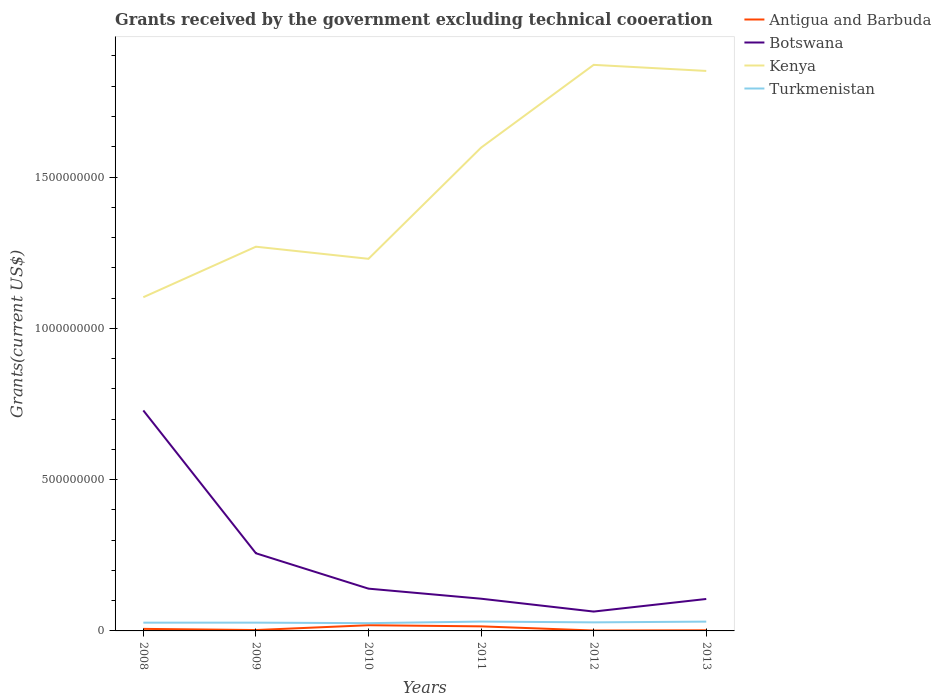Across all years, what is the maximum total grants received by the government in Turkmenistan?
Provide a short and direct response. 2.57e+07. In which year was the total grants received by the government in Turkmenistan maximum?
Your response must be concise. 2010. What is the total total grants received by the government in Turkmenistan in the graph?
Your response must be concise. -3.51e+06. What is the difference between the highest and the second highest total grants received by the government in Botswana?
Provide a succinct answer. 6.65e+08. What is the difference between the highest and the lowest total grants received by the government in Turkmenistan?
Provide a short and direct response. 2. Is the total grants received by the government in Botswana strictly greater than the total grants received by the government in Antigua and Barbuda over the years?
Give a very brief answer. No. How many lines are there?
Provide a succinct answer. 4. How many years are there in the graph?
Provide a short and direct response. 6. What is the difference between two consecutive major ticks on the Y-axis?
Make the answer very short. 5.00e+08. Are the values on the major ticks of Y-axis written in scientific E-notation?
Make the answer very short. No. Where does the legend appear in the graph?
Provide a short and direct response. Top right. How many legend labels are there?
Ensure brevity in your answer.  4. How are the legend labels stacked?
Provide a succinct answer. Vertical. What is the title of the graph?
Ensure brevity in your answer.  Grants received by the government excluding technical cooeration. What is the label or title of the Y-axis?
Offer a terse response. Grants(current US$). What is the Grants(current US$) in Antigua and Barbuda in 2008?
Your response must be concise. 6.78e+06. What is the Grants(current US$) in Botswana in 2008?
Ensure brevity in your answer.  7.29e+08. What is the Grants(current US$) in Kenya in 2008?
Keep it short and to the point. 1.10e+09. What is the Grants(current US$) in Turkmenistan in 2008?
Your answer should be compact. 2.73e+07. What is the Grants(current US$) of Antigua and Barbuda in 2009?
Provide a short and direct response. 2.92e+06. What is the Grants(current US$) of Botswana in 2009?
Your answer should be very brief. 2.57e+08. What is the Grants(current US$) in Kenya in 2009?
Ensure brevity in your answer.  1.27e+09. What is the Grants(current US$) of Turkmenistan in 2009?
Keep it short and to the point. 2.74e+07. What is the Grants(current US$) in Antigua and Barbuda in 2010?
Ensure brevity in your answer.  1.88e+07. What is the Grants(current US$) of Botswana in 2010?
Give a very brief answer. 1.40e+08. What is the Grants(current US$) in Kenya in 2010?
Keep it short and to the point. 1.23e+09. What is the Grants(current US$) of Turkmenistan in 2010?
Offer a terse response. 2.57e+07. What is the Grants(current US$) in Antigua and Barbuda in 2011?
Provide a succinct answer. 1.51e+07. What is the Grants(current US$) of Botswana in 2011?
Provide a short and direct response. 1.06e+08. What is the Grants(current US$) in Kenya in 2011?
Your response must be concise. 1.60e+09. What is the Grants(current US$) in Turkmenistan in 2011?
Provide a succinct answer. 3.09e+07. What is the Grants(current US$) in Antigua and Barbuda in 2012?
Provide a short and direct response. 1.38e+06. What is the Grants(current US$) in Botswana in 2012?
Provide a succinct answer. 6.40e+07. What is the Grants(current US$) of Kenya in 2012?
Ensure brevity in your answer.  1.87e+09. What is the Grants(current US$) in Turkmenistan in 2012?
Keep it short and to the point. 2.83e+07. What is the Grants(current US$) in Antigua and Barbuda in 2013?
Keep it short and to the point. 2.06e+06. What is the Grants(current US$) in Botswana in 2013?
Your answer should be compact. 1.06e+08. What is the Grants(current US$) of Kenya in 2013?
Provide a succinct answer. 1.85e+09. What is the Grants(current US$) of Turkmenistan in 2013?
Your response must be concise. 3.07e+07. Across all years, what is the maximum Grants(current US$) of Antigua and Barbuda?
Provide a succinct answer. 1.88e+07. Across all years, what is the maximum Grants(current US$) in Botswana?
Keep it short and to the point. 7.29e+08. Across all years, what is the maximum Grants(current US$) in Kenya?
Your response must be concise. 1.87e+09. Across all years, what is the maximum Grants(current US$) in Turkmenistan?
Give a very brief answer. 3.09e+07. Across all years, what is the minimum Grants(current US$) in Antigua and Barbuda?
Give a very brief answer. 1.38e+06. Across all years, what is the minimum Grants(current US$) of Botswana?
Make the answer very short. 6.40e+07. Across all years, what is the minimum Grants(current US$) in Kenya?
Provide a short and direct response. 1.10e+09. Across all years, what is the minimum Grants(current US$) in Turkmenistan?
Ensure brevity in your answer.  2.57e+07. What is the total Grants(current US$) in Antigua and Barbuda in the graph?
Offer a terse response. 4.70e+07. What is the total Grants(current US$) in Botswana in the graph?
Offer a terse response. 1.40e+09. What is the total Grants(current US$) of Kenya in the graph?
Provide a succinct answer. 8.92e+09. What is the total Grants(current US$) in Turkmenistan in the graph?
Your answer should be very brief. 1.70e+08. What is the difference between the Grants(current US$) in Antigua and Barbuda in 2008 and that in 2009?
Provide a succinct answer. 3.86e+06. What is the difference between the Grants(current US$) of Botswana in 2008 and that in 2009?
Keep it short and to the point. 4.72e+08. What is the difference between the Grants(current US$) in Kenya in 2008 and that in 2009?
Your response must be concise. -1.67e+08. What is the difference between the Grants(current US$) in Turkmenistan in 2008 and that in 2009?
Your answer should be compact. -6.00e+04. What is the difference between the Grants(current US$) in Antigua and Barbuda in 2008 and that in 2010?
Make the answer very short. -1.20e+07. What is the difference between the Grants(current US$) in Botswana in 2008 and that in 2010?
Offer a terse response. 5.89e+08. What is the difference between the Grants(current US$) in Kenya in 2008 and that in 2010?
Keep it short and to the point. -1.27e+08. What is the difference between the Grants(current US$) of Turkmenistan in 2008 and that in 2010?
Provide a short and direct response. 1.63e+06. What is the difference between the Grants(current US$) of Antigua and Barbuda in 2008 and that in 2011?
Offer a very short reply. -8.28e+06. What is the difference between the Grants(current US$) in Botswana in 2008 and that in 2011?
Your response must be concise. 6.22e+08. What is the difference between the Grants(current US$) of Kenya in 2008 and that in 2011?
Your response must be concise. -4.94e+08. What is the difference between the Grants(current US$) of Turkmenistan in 2008 and that in 2011?
Your answer should be very brief. -3.57e+06. What is the difference between the Grants(current US$) of Antigua and Barbuda in 2008 and that in 2012?
Your answer should be compact. 5.40e+06. What is the difference between the Grants(current US$) of Botswana in 2008 and that in 2012?
Your answer should be compact. 6.65e+08. What is the difference between the Grants(current US$) of Kenya in 2008 and that in 2012?
Provide a succinct answer. -7.68e+08. What is the difference between the Grants(current US$) of Turkmenistan in 2008 and that in 2012?
Give a very brief answer. -9.90e+05. What is the difference between the Grants(current US$) in Antigua and Barbuda in 2008 and that in 2013?
Provide a succinct answer. 4.72e+06. What is the difference between the Grants(current US$) of Botswana in 2008 and that in 2013?
Provide a short and direct response. 6.23e+08. What is the difference between the Grants(current US$) in Kenya in 2008 and that in 2013?
Your answer should be very brief. -7.48e+08. What is the difference between the Grants(current US$) of Turkmenistan in 2008 and that in 2013?
Your response must be concise. -3.41e+06. What is the difference between the Grants(current US$) of Antigua and Barbuda in 2009 and that in 2010?
Provide a succinct answer. -1.59e+07. What is the difference between the Grants(current US$) in Botswana in 2009 and that in 2010?
Give a very brief answer. 1.17e+08. What is the difference between the Grants(current US$) of Kenya in 2009 and that in 2010?
Provide a succinct answer. 4.00e+07. What is the difference between the Grants(current US$) of Turkmenistan in 2009 and that in 2010?
Keep it short and to the point. 1.69e+06. What is the difference between the Grants(current US$) in Antigua and Barbuda in 2009 and that in 2011?
Offer a terse response. -1.21e+07. What is the difference between the Grants(current US$) of Botswana in 2009 and that in 2011?
Provide a short and direct response. 1.50e+08. What is the difference between the Grants(current US$) of Kenya in 2009 and that in 2011?
Your answer should be very brief. -3.27e+08. What is the difference between the Grants(current US$) of Turkmenistan in 2009 and that in 2011?
Make the answer very short. -3.51e+06. What is the difference between the Grants(current US$) of Antigua and Barbuda in 2009 and that in 2012?
Give a very brief answer. 1.54e+06. What is the difference between the Grants(current US$) of Botswana in 2009 and that in 2012?
Keep it short and to the point. 1.93e+08. What is the difference between the Grants(current US$) in Kenya in 2009 and that in 2012?
Give a very brief answer. -6.01e+08. What is the difference between the Grants(current US$) in Turkmenistan in 2009 and that in 2012?
Offer a terse response. -9.30e+05. What is the difference between the Grants(current US$) of Antigua and Barbuda in 2009 and that in 2013?
Give a very brief answer. 8.60e+05. What is the difference between the Grants(current US$) in Botswana in 2009 and that in 2013?
Your answer should be compact. 1.51e+08. What is the difference between the Grants(current US$) of Kenya in 2009 and that in 2013?
Your answer should be very brief. -5.81e+08. What is the difference between the Grants(current US$) in Turkmenistan in 2009 and that in 2013?
Ensure brevity in your answer.  -3.35e+06. What is the difference between the Grants(current US$) of Antigua and Barbuda in 2010 and that in 2011?
Provide a short and direct response. 3.77e+06. What is the difference between the Grants(current US$) in Botswana in 2010 and that in 2011?
Provide a short and direct response. 3.32e+07. What is the difference between the Grants(current US$) in Kenya in 2010 and that in 2011?
Your answer should be compact. -3.67e+08. What is the difference between the Grants(current US$) of Turkmenistan in 2010 and that in 2011?
Give a very brief answer. -5.20e+06. What is the difference between the Grants(current US$) in Antigua and Barbuda in 2010 and that in 2012?
Make the answer very short. 1.74e+07. What is the difference between the Grants(current US$) in Botswana in 2010 and that in 2012?
Provide a succinct answer. 7.57e+07. What is the difference between the Grants(current US$) in Kenya in 2010 and that in 2012?
Keep it short and to the point. -6.41e+08. What is the difference between the Grants(current US$) of Turkmenistan in 2010 and that in 2012?
Give a very brief answer. -2.62e+06. What is the difference between the Grants(current US$) of Antigua and Barbuda in 2010 and that in 2013?
Your answer should be compact. 1.68e+07. What is the difference between the Grants(current US$) in Botswana in 2010 and that in 2013?
Offer a very short reply. 3.41e+07. What is the difference between the Grants(current US$) in Kenya in 2010 and that in 2013?
Keep it short and to the point. -6.21e+08. What is the difference between the Grants(current US$) of Turkmenistan in 2010 and that in 2013?
Your answer should be compact. -5.04e+06. What is the difference between the Grants(current US$) of Antigua and Barbuda in 2011 and that in 2012?
Your answer should be compact. 1.37e+07. What is the difference between the Grants(current US$) of Botswana in 2011 and that in 2012?
Your answer should be compact. 4.25e+07. What is the difference between the Grants(current US$) of Kenya in 2011 and that in 2012?
Your answer should be very brief. -2.74e+08. What is the difference between the Grants(current US$) of Turkmenistan in 2011 and that in 2012?
Your answer should be compact. 2.58e+06. What is the difference between the Grants(current US$) of Antigua and Barbuda in 2011 and that in 2013?
Your answer should be very brief. 1.30e+07. What is the difference between the Grants(current US$) in Botswana in 2011 and that in 2013?
Keep it short and to the point. 8.70e+05. What is the difference between the Grants(current US$) of Kenya in 2011 and that in 2013?
Provide a succinct answer. -2.53e+08. What is the difference between the Grants(current US$) of Turkmenistan in 2011 and that in 2013?
Give a very brief answer. 1.60e+05. What is the difference between the Grants(current US$) of Antigua and Barbuda in 2012 and that in 2013?
Your answer should be very brief. -6.80e+05. What is the difference between the Grants(current US$) of Botswana in 2012 and that in 2013?
Provide a succinct answer. -4.16e+07. What is the difference between the Grants(current US$) of Kenya in 2012 and that in 2013?
Offer a very short reply. 2.01e+07. What is the difference between the Grants(current US$) of Turkmenistan in 2012 and that in 2013?
Your answer should be compact. -2.42e+06. What is the difference between the Grants(current US$) of Antigua and Barbuda in 2008 and the Grants(current US$) of Botswana in 2009?
Offer a very short reply. -2.50e+08. What is the difference between the Grants(current US$) in Antigua and Barbuda in 2008 and the Grants(current US$) in Kenya in 2009?
Give a very brief answer. -1.26e+09. What is the difference between the Grants(current US$) in Antigua and Barbuda in 2008 and the Grants(current US$) in Turkmenistan in 2009?
Your response must be concise. -2.06e+07. What is the difference between the Grants(current US$) in Botswana in 2008 and the Grants(current US$) in Kenya in 2009?
Give a very brief answer. -5.41e+08. What is the difference between the Grants(current US$) of Botswana in 2008 and the Grants(current US$) of Turkmenistan in 2009?
Provide a succinct answer. 7.01e+08. What is the difference between the Grants(current US$) of Kenya in 2008 and the Grants(current US$) of Turkmenistan in 2009?
Provide a succinct answer. 1.08e+09. What is the difference between the Grants(current US$) in Antigua and Barbuda in 2008 and the Grants(current US$) in Botswana in 2010?
Your answer should be compact. -1.33e+08. What is the difference between the Grants(current US$) of Antigua and Barbuda in 2008 and the Grants(current US$) of Kenya in 2010?
Provide a succinct answer. -1.22e+09. What is the difference between the Grants(current US$) of Antigua and Barbuda in 2008 and the Grants(current US$) of Turkmenistan in 2010?
Your response must be concise. -1.89e+07. What is the difference between the Grants(current US$) of Botswana in 2008 and the Grants(current US$) of Kenya in 2010?
Your answer should be very brief. -5.01e+08. What is the difference between the Grants(current US$) in Botswana in 2008 and the Grants(current US$) in Turkmenistan in 2010?
Your response must be concise. 7.03e+08. What is the difference between the Grants(current US$) in Kenya in 2008 and the Grants(current US$) in Turkmenistan in 2010?
Your response must be concise. 1.08e+09. What is the difference between the Grants(current US$) of Antigua and Barbuda in 2008 and the Grants(current US$) of Botswana in 2011?
Give a very brief answer. -9.97e+07. What is the difference between the Grants(current US$) in Antigua and Barbuda in 2008 and the Grants(current US$) in Kenya in 2011?
Your answer should be compact. -1.59e+09. What is the difference between the Grants(current US$) of Antigua and Barbuda in 2008 and the Grants(current US$) of Turkmenistan in 2011?
Provide a succinct answer. -2.41e+07. What is the difference between the Grants(current US$) in Botswana in 2008 and the Grants(current US$) in Kenya in 2011?
Offer a terse response. -8.69e+08. What is the difference between the Grants(current US$) in Botswana in 2008 and the Grants(current US$) in Turkmenistan in 2011?
Offer a very short reply. 6.98e+08. What is the difference between the Grants(current US$) of Kenya in 2008 and the Grants(current US$) of Turkmenistan in 2011?
Ensure brevity in your answer.  1.07e+09. What is the difference between the Grants(current US$) of Antigua and Barbuda in 2008 and the Grants(current US$) of Botswana in 2012?
Offer a very short reply. -5.72e+07. What is the difference between the Grants(current US$) in Antigua and Barbuda in 2008 and the Grants(current US$) in Kenya in 2012?
Make the answer very short. -1.86e+09. What is the difference between the Grants(current US$) of Antigua and Barbuda in 2008 and the Grants(current US$) of Turkmenistan in 2012?
Provide a succinct answer. -2.15e+07. What is the difference between the Grants(current US$) in Botswana in 2008 and the Grants(current US$) in Kenya in 2012?
Ensure brevity in your answer.  -1.14e+09. What is the difference between the Grants(current US$) of Botswana in 2008 and the Grants(current US$) of Turkmenistan in 2012?
Keep it short and to the point. 7.00e+08. What is the difference between the Grants(current US$) of Kenya in 2008 and the Grants(current US$) of Turkmenistan in 2012?
Make the answer very short. 1.07e+09. What is the difference between the Grants(current US$) of Antigua and Barbuda in 2008 and the Grants(current US$) of Botswana in 2013?
Your answer should be very brief. -9.88e+07. What is the difference between the Grants(current US$) in Antigua and Barbuda in 2008 and the Grants(current US$) in Kenya in 2013?
Your answer should be compact. -1.84e+09. What is the difference between the Grants(current US$) of Antigua and Barbuda in 2008 and the Grants(current US$) of Turkmenistan in 2013?
Provide a succinct answer. -2.39e+07. What is the difference between the Grants(current US$) in Botswana in 2008 and the Grants(current US$) in Kenya in 2013?
Keep it short and to the point. -1.12e+09. What is the difference between the Grants(current US$) in Botswana in 2008 and the Grants(current US$) in Turkmenistan in 2013?
Keep it short and to the point. 6.98e+08. What is the difference between the Grants(current US$) in Kenya in 2008 and the Grants(current US$) in Turkmenistan in 2013?
Offer a very short reply. 1.07e+09. What is the difference between the Grants(current US$) of Antigua and Barbuda in 2009 and the Grants(current US$) of Botswana in 2010?
Provide a succinct answer. -1.37e+08. What is the difference between the Grants(current US$) in Antigua and Barbuda in 2009 and the Grants(current US$) in Kenya in 2010?
Provide a short and direct response. -1.23e+09. What is the difference between the Grants(current US$) in Antigua and Barbuda in 2009 and the Grants(current US$) in Turkmenistan in 2010?
Ensure brevity in your answer.  -2.28e+07. What is the difference between the Grants(current US$) of Botswana in 2009 and the Grants(current US$) of Kenya in 2010?
Your answer should be very brief. -9.73e+08. What is the difference between the Grants(current US$) in Botswana in 2009 and the Grants(current US$) in Turkmenistan in 2010?
Your response must be concise. 2.31e+08. What is the difference between the Grants(current US$) of Kenya in 2009 and the Grants(current US$) of Turkmenistan in 2010?
Provide a short and direct response. 1.24e+09. What is the difference between the Grants(current US$) in Antigua and Barbuda in 2009 and the Grants(current US$) in Botswana in 2011?
Provide a succinct answer. -1.04e+08. What is the difference between the Grants(current US$) of Antigua and Barbuda in 2009 and the Grants(current US$) of Kenya in 2011?
Ensure brevity in your answer.  -1.59e+09. What is the difference between the Grants(current US$) in Antigua and Barbuda in 2009 and the Grants(current US$) in Turkmenistan in 2011?
Your answer should be very brief. -2.80e+07. What is the difference between the Grants(current US$) in Botswana in 2009 and the Grants(current US$) in Kenya in 2011?
Provide a short and direct response. -1.34e+09. What is the difference between the Grants(current US$) of Botswana in 2009 and the Grants(current US$) of Turkmenistan in 2011?
Ensure brevity in your answer.  2.26e+08. What is the difference between the Grants(current US$) in Kenya in 2009 and the Grants(current US$) in Turkmenistan in 2011?
Your answer should be compact. 1.24e+09. What is the difference between the Grants(current US$) of Antigua and Barbuda in 2009 and the Grants(current US$) of Botswana in 2012?
Keep it short and to the point. -6.10e+07. What is the difference between the Grants(current US$) in Antigua and Barbuda in 2009 and the Grants(current US$) in Kenya in 2012?
Provide a succinct answer. -1.87e+09. What is the difference between the Grants(current US$) in Antigua and Barbuda in 2009 and the Grants(current US$) in Turkmenistan in 2012?
Provide a short and direct response. -2.54e+07. What is the difference between the Grants(current US$) of Botswana in 2009 and the Grants(current US$) of Kenya in 2012?
Offer a terse response. -1.61e+09. What is the difference between the Grants(current US$) in Botswana in 2009 and the Grants(current US$) in Turkmenistan in 2012?
Ensure brevity in your answer.  2.28e+08. What is the difference between the Grants(current US$) in Kenya in 2009 and the Grants(current US$) in Turkmenistan in 2012?
Your answer should be compact. 1.24e+09. What is the difference between the Grants(current US$) of Antigua and Barbuda in 2009 and the Grants(current US$) of Botswana in 2013?
Make the answer very short. -1.03e+08. What is the difference between the Grants(current US$) in Antigua and Barbuda in 2009 and the Grants(current US$) in Kenya in 2013?
Your answer should be compact. -1.85e+09. What is the difference between the Grants(current US$) of Antigua and Barbuda in 2009 and the Grants(current US$) of Turkmenistan in 2013?
Make the answer very short. -2.78e+07. What is the difference between the Grants(current US$) of Botswana in 2009 and the Grants(current US$) of Kenya in 2013?
Your response must be concise. -1.59e+09. What is the difference between the Grants(current US$) of Botswana in 2009 and the Grants(current US$) of Turkmenistan in 2013?
Ensure brevity in your answer.  2.26e+08. What is the difference between the Grants(current US$) in Kenya in 2009 and the Grants(current US$) in Turkmenistan in 2013?
Keep it short and to the point. 1.24e+09. What is the difference between the Grants(current US$) in Antigua and Barbuda in 2010 and the Grants(current US$) in Botswana in 2011?
Provide a succinct answer. -8.76e+07. What is the difference between the Grants(current US$) in Antigua and Barbuda in 2010 and the Grants(current US$) in Kenya in 2011?
Your answer should be very brief. -1.58e+09. What is the difference between the Grants(current US$) of Antigua and Barbuda in 2010 and the Grants(current US$) of Turkmenistan in 2011?
Your answer should be compact. -1.20e+07. What is the difference between the Grants(current US$) in Botswana in 2010 and the Grants(current US$) in Kenya in 2011?
Offer a terse response. -1.46e+09. What is the difference between the Grants(current US$) in Botswana in 2010 and the Grants(current US$) in Turkmenistan in 2011?
Offer a terse response. 1.09e+08. What is the difference between the Grants(current US$) of Kenya in 2010 and the Grants(current US$) of Turkmenistan in 2011?
Your answer should be compact. 1.20e+09. What is the difference between the Grants(current US$) of Antigua and Barbuda in 2010 and the Grants(current US$) of Botswana in 2012?
Your response must be concise. -4.51e+07. What is the difference between the Grants(current US$) in Antigua and Barbuda in 2010 and the Grants(current US$) in Kenya in 2012?
Keep it short and to the point. -1.85e+09. What is the difference between the Grants(current US$) of Antigua and Barbuda in 2010 and the Grants(current US$) of Turkmenistan in 2012?
Offer a very short reply. -9.46e+06. What is the difference between the Grants(current US$) in Botswana in 2010 and the Grants(current US$) in Kenya in 2012?
Give a very brief answer. -1.73e+09. What is the difference between the Grants(current US$) of Botswana in 2010 and the Grants(current US$) of Turkmenistan in 2012?
Your answer should be very brief. 1.11e+08. What is the difference between the Grants(current US$) in Kenya in 2010 and the Grants(current US$) in Turkmenistan in 2012?
Make the answer very short. 1.20e+09. What is the difference between the Grants(current US$) of Antigua and Barbuda in 2010 and the Grants(current US$) of Botswana in 2013?
Keep it short and to the point. -8.68e+07. What is the difference between the Grants(current US$) in Antigua and Barbuda in 2010 and the Grants(current US$) in Kenya in 2013?
Your response must be concise. -1.83e+09. What is the difference between the Grants(current US$) in Antigua and Barbuda in 2010 and the Grants(current US$) in Turkmenistan in 2013?
Your answer should be compact. -1.19e+07. What is the difference between the Grants(current US$) of Botswana in 2010 and the Grants(current US$) of Kenya in 2013?
Offer a very short reply. -1.71e+09. What is the difference between the Grants(current US$) of Botswana in 2010 and the Grants(current US$) of Turkmenistan in 2013?
Keep it short and to the point. 1.09e+08. What is the difference between the Grants(current US$) of Kenya in 2010 and the Grants(current US$) of Turkmenistan in 2013?
Provide a succinct answer. 1.20e+09. What is the difference between the Grants(current US$) in Antigua and Barbuda in 2011 and the Grants(current US$) in Botswana in 2012?
Your answer should be compact. -4.89e+07. What is the difference between the Grants(current US$) in Antigua and Barbuda in 2011 and the Grants(current US$) in Kenya in 2012?
Make the answer very short. -1.86e+09. What is the difference between the Grants(current US$) in Antigua and Barbuda in 2011 and the Grants(current US$) in Turkmenistan in 2012?
Your answer should be compact. -1.32e+07. What is the difference between the Grants(current US$) in Botswana in 2011 and the Grants(current US$) in Kenya in 2012?
Provide a succinct answer. -1.76e+09. What is the difference between the Grants(current US$) in Botswana in 2011 and the Grants(current US$) in Turkmenistan in 2012?
Offer a terse response. 7.82e+07. What is the difference between the Grants(current US$) in Kenya in 2011 and the Grants(current US$) in Turkmenistan in 2012?
Ensure brevity in your answer.  1.57e+09. What is the difference between the Grants(current US$) in Antigua and Barbuda in 2011 and the Grants(current US$) in Botswana in 2013?
Provide a short and direct response. -9.05e+07. What is the difference between the Grants(current US$) in Antigua and Barbuda in 2011 and the Grants(current US$) in Kenya in 2013?
Provide a short and direct response. -1.84e+09. What is the difference between the Grants(current US$) of Antigua and Barbuda in 2011 and the Grants(current US$) of Turkmenistan in 2013?
Make the answer very short. -1.56e+07. What is the difference between the Grants(current US$) in Botswana in 2011 and the Grants(current US$) in Kenya in 2013?
Offer a very short reply. -1.74e+09. What is the difference between the Grants(current US$) in Botswana in 2011 and the Grants(current US$) in Turkmenistan in 2013?
Provide a succinct answer. 7.57e+07. What is the difference between the Grants(current US$) of Kenya in 2011 and the Grants(current US$) of Turkmenistan in 2013?
Offer a very short reply. 1.57e+09. What is the difference between the Grants(current US$) of Antigua and Barbuda in 2012 and the Grants(current US$) of Botswana in 2013?
Keep it short and to the point. -1.04e+08. What is the difference between the Grants(current US$) of Antigua and Barbuda in 2012 and the Grants(current US$) of Kenya in 2013?
Give a very brief answer. -1.85e+09. What is the difference between the Grants(current US$) of Antigua and Barbuda in 2012 and the Grants(current US$) of Turkmenistan in 2013?
Keep it short and to the point. -2.93e+07. What is the difference between the Grants(current US$) of Botswana in 2012 and the Grants(current US$) of Kenya in 2013?
Ensure brevity in your answer.  -1.79e+09. What is the difference between the Grants(current US$) of Botswana in 2012 and the Grants(current US$) of Turkmenistan in 2013?
Your answer should be compact. 3.33e+07. What is the difference between the Grants(current US$) of Kenya in 2012 and the Grants(current US$) of Turkmenistan in 2013?
Your response must be concise. 1.84e+09. What is the average Grants(current US$) of Antigua and Barbuda per year?
Provide a short and direct response. 7.84e+06. What is the average Grants(current US$) of Botswana per year?
Provide a succinct answer. 2.33e+08. What is the average Grants(current US$) in Kenya per year?
Offer a very short reply. 1.49e+09. What is the average Grants(current US$) in Turkmenistan per year?
Your answer should be very brief. 2.84e+07. In the year 2008, what is the difference between the Grants(current US$) in Antigua and Barbuda and Grants(current US$) in Botswana?
Offer a very short reply. -7.22e+08. In the year 2008, what is the difference between the Grants(current US$) in Antigua and Barbuda and Grants(current US$) in Kenya?
Your response must be concise. -1.10e+09. In the year 2008, what is the difference between the Grants(current US$) of Antigua and Barbuda and Grants(current US$) of Turkmenistan?
Your answer should be compact. -2.05e+07. In the year 2008, what is the difference between the Grants(current US$) in Botswana and Grants(current US$) in Kenya?
Make the answer very short. -3.74e+08. In the year 2008, what is the difference between the Grants(current US$) of Botswana and Grants(current US$) of Turkmenistan?
Offer a terse response. 7.01e+08. In the year 2008, what is the difference between the Grants(current US$) of Kenya and Grants(current US$) of Turkmenistan?
Your answer should be compact. 1.08e+09. In the year 2009, what is the difference between the Grants(current US$) of Antigua and Barbuda and Grants(current US$) of Botswana?
Your answer should be very brief. -2.54e+08. In the year 2009, what is the difference between the Grants(current US$) of Antigua and Barbuda and Grants(current US$) of Kenya?
Make the answer very short. -1.27e+09. In the year 2009, what is the difference between the Grants(current US$) in Antigua and Barbuda and Grants(current US$) in Turkmenistan?
Your response must be concise. -2.44e+07. In the year 2009, what is the difference between the Grants(current US$) of Botswana and Grants(current US$) of Kenya?
Give a very brief answer. -1.01e+09. In the year 2009, what is the difference between the Grants(current US$) in Botswana and Grants(current US$) in Turkmenistan?
Your answer should be compact. 2.29e+08. In the year 2009, what is the difference between the Grants(current US$) in Kenya and Grants(current US$) in Turkmenistan?
Keep it short and to the point. 1.24e+09. In the year 2010, what is the difference between the Grants(current US$) of Antigua and Barbuda and Grants(current US$) of Botswana?
Offer a terse response. -1.21e+08. In the year 2010, what is the difference between the Grants(current US$) in Antigua and Barbuda and Grants(current US$) in Kenya?
Provide a succinct answer. -1.21e+09. In the year 2010, what is the difference between the Grants(current US$) in Antigua and Barbuda and Grants(current US$) in Turkmenistan?
Offer a very short reply. -6.84e+06. In the year 2010, what is the difference between the Grants(current US$) of Botswana and Grants(current US$) of Kenya?
Ensure brevity in your answer.  -1.09e+09. In the year 2010, what is the difference between the Grants(current US$) in Botswana and Grants(current US$) in Turkmenistan?
Provide a succinct answer. 1.14e+08. In the year 2010, what is the difference between the Grants(current US$) of Kenya and Grants(current US$) of Turkmenistan?
Keep it short and to the point. 1.20e+09. In the year 2011, what is the difference between the Grants(current US$) of Antigua and Barbuda and Grants(current US$) of Botswana?
Your answer should be compact. -9.14e+07. In the year 2011, what is the difference between the Grants(current US$) in Antigua and Barbuda and Grants(current US$) in Kenya?
Give a very brief answer. -1.58e+09. In the year 2011, what is the difference between the Grants(current US$) of Antigua and Barbuda and Grants(current US$) of Turkmenistan?
Offer a terse response. -1.58e+07. In the year 2011, what is the difference between the Grants(current US$) in Botswana and Grants(current US$) in Kenya?
Ensure brevity in your answer.  -1.49e+09. In the year 2011, what is the difference between the Grants(current US$) in Botswana and Grants(current US$) in Turkmenistan?
Offer a very short reply. 7.56e+07. In the year 2011, what is the difference between the Grants(current US$) in Kenya and Grants(current US$) in Turkmenistan?
Your answer should be very brief. 1.57e+09. In the year 2012, what is the difference between the Grants(current US$) in Antigua and Barbuda and Grants(current US$) in Botswana?
Give a very brief answer. -6.26e+07. In the year 2012, what is the difference between the Grants(current US$) of Antigua and Barbuda and Grants(current US$) of Kenya?
Offer a very short reply. -1.87e+09. In the year 2012, what is the difference between the Grants(current US$) in Antigua and Barbuda and Grants(current US$) in Turkmenistan?
Keep it short and to the point. -2.69e+07. In the year 2012, what is the difference between the Grants(current US$) in Botswana and Grants(current US$) in Kenya?
Your answer should be compact. -1.81e+09. In the year 2012, what is the difference between the Grants(current US$) of Botswana and Grants(current US$) of Turkmenistan?
Ensure brevity in your answer.  3.57e+07. In the year 2012, what is the difference between the Grants(current US$) in Kenya and Grants(current US$) in Turkmenistan?
Offer a terse response. 1.84e+09. In the year 2013, what is the difference between the Grants(current US$) in Antigua and Barbuda and Grants(current US$) in Botswana?
Give a very brief answer. -1.04e+08. In the year 2013, what is the difference between the Grants(current US$) in Antigua and Barbuda and Grants(current US$) in Kenya?
Your answer should be compact. -1.85e+09. In the year 2013, what is the difference between the Grants(current US$) of Antigua and Barbuda and Grants(current US$) of Turkmenistan?
Your answer should be compact. -2.86e+07. In the year 2013, what is the difference between the Grants(current US$) of Botswana and Grants(current US$) of Kenya?
Your answer should be very brief. -1.74e+09. In the year 2013, what is the difference between the Grants(current US$) of Botswana and Grants(current US$) of Turkmenistan?
Ensure brevity in your answer.  7.49e+07. In the year 2013, what is the difference between the Grants(current US$) of Kenya and Grants(current US$) of Turkmenistan?
Keep it short and to the point. 1.82e+09. What is the ratio of the Grants(current US$) of Antigua and Barbuda in 2008 to that in 2009?
Keep it short and to the point. 2.32. What is the ratio of the Grants(current US$) of Botswana in 2008 to that in 2009?
Your answer should be compact. 2.84. What is the ratio of the Grants(current US$) of Kenya in 2008 to that in 2009?
Offer a very short reply. 0.87. What is the ratio of the Grants(current US$) of Antigua and Barbuda in 2008 to that in 2010?
Your answer should be compact. 0.36. What is the ratio of the Grants(current US$) of Botswana in 2008 to that in 2010?
Ensure brevity in your answer.  5.22. What is the ratio of the Grants(current US$) of Kenya in 2008 to that in 2010?
Your response must be concise. 0.9. What is the ratio of the Grants(current US$) of Turkmenistan in 2008 to that in 2010?
Offer a very short reply. 1.06. What is the ratio of the Grants(current US$) in Antigua and Barbuda in 2008 to that in 2011?
Your answer should be very brief. 0.45. What is the ratio of the Grants(current US$) of Botswana in 2008 to that in 2011?
Your answer should be compact. 6.84. What is the ratio of the Grants(current US$) in Kenya in 2008 to that in 2011?
Give a very brief answer. 0.69. What is the ratio of the Grants(current US$) in Turkmenistan in 2008 to that in 2011?
Ensure brevity in your answer.  0.88. What is the ratio of the Grants(current US$) of Antigua and Barbuda in 2008 to that in 2012?
Keep it short and to the point. 4.91. What is the ratio of the Grants(current US$) of Botswana in 2008 to that in 2012?
Make the answer very short. 11.39. What is the ratio of the Grants(current US$) of Kenya in 2008 to that in 2012?
Provide a short and direct response. 0.59. What is the ratio of the Grants(current US$) of Turkmenistan in 2008 to that in 2012?
Provide a succinct answer. 0.96. What is the ratio of the Grants(current US$) of Antigua and Barbuda in 2008 to that in 2013?
Offer a terse response. 3.29. What is the ratio of the Grants(current US$) in Botswana in 2008 to that in 2013?
Provide a short and direct response. 6.9. What is the ratio of the Grants(current US$) in Kenya in 2008 to that in 2013?
Keep it short and to the point. 0.6. What is the ratio of the Grants(current US$) of Turkmenistan in 2008 to that in 2013?
Provide a short and direct response. 0.89. What is the ratio of the Grants(current US$) in Antigua and Barbuda in 2009 to that in 2010?
Offer a very short reply. 0.16. What is the ratio of the Grants(current US$) in Botswana in 2009 to that in 2010?
Provide a succinct answer. 1.84. What is the ratio of the Grants(current US$) of Kenya in 2009 to that in 2010?
Ensure brevity in your answer.  1.03. What is the ratio of the Grants(current US$) of Turkmenistan in 2009 to that in 2010?
Make the answer very short. 1.07. What is the ratio of the Grants(current US$) of Antigua and Barbuda in 2009 to that in 2011?
Give a very brief answer. 0.19. What is the ratio of the Grants(current US$) of Botswana in 2009 to that in 2011?
Your answer should be compact. 2.41. What is the ratio of the Grants(current US$) of Kenya in 2009 to that in 2011?
Provide a succinct answer. 0.8. What is the ratio of the Grants(current US$) of Turkmenistan in 2009 to that in 2011?
Your answer should be compact. 0.89. What is the ratio of the Grants(current US$) in Antigua and Barbuda in 2009 to that in 2012?
Offer a terse response. 2.12. What is the ratio of the Grants(current US$) in Botswana in 2009 to that in 2012?
Offer a very short reply. 4.01. What is the ratio of the Grants(current US$) in Kenya in 2009 to that in 2012?
Make the answer very short. 0.68. What is the ratio of the Grants(current US$) in Turkmenistan in 2009 to that in 2012?
Your answer should be very brief. 0.97. What is the ratio of the Grants(current US$) in Antigua and Barbuda in 2009 to that in 2013?
Ensure brevity in your answer.  1.42. What is the ratio of the Grants(current US$) in Botswana in 2009 to that in 2013?
Ensure brevity in your answer.  2.43. What is the ratio of the Grants(current US$) of Kenya in 2009 to that in 2013?
Your answer should be very brief. 0.69. What is the ratio of the Grants(current US$) in Turkmenistan in 2009 to that in 2013?
Your answer should be very brief. 0.89. What is the ratio of the Grants(current US$) in Antigua and Barbuda in 2010 to that in 2011?
Provide a short and direct response. 1.25. What is the ratio of the Grants(current US$) in Botswana in 2010 to that in 2011?
Your answer should be compact. 1.31. What is the ratio of the Grants(current US$) in Kenya in 2010 to that in 2011?
Provide a succinct answer. 0.77. What is the ratio of the Grants(current US$) of Turkmenistan in 2010 to that in 2011?
Provide a short and direct response. 0.83. What is the ratio of the Grants(current US$) in Antigua and Barbuda in 2010 to that in 2012?
Ensure brevity in your answer.  13.64. What is the ratio of the Grants(current US$) of Botswana in 2010 to that in 2012?
Your answer should be compact. 2.18. What is the ratio of the Grants(current US$) of Kenya in 2010 to that in 2012?
Ensure brevity in your answer.  0.66. What is the ratio of the Grants(current US$) in Turkmenistan in 2010 to that in 2012?
Your answer should be compact. 0.91. What is the ratio of the Grants(current US$) of Antigua and Barbuda in 2010 to that in 2013?
Your answer should be very brief. 9.14. What is the ratio of the Grants(current US$) of Botswana in 2010 to that in 2013?
Give a very brief answer. 1.32. What is the ratio of the Grants(current US$) of Kenya in 2010 to that in 2013?
Provide a succinct answer. 0.66. What is the ratio of the Grants(current US$) of Turkmenistan in 2010 to that in 2013?
Offer a terse response. 0.84. What is the ratio of the Grants(current US$) of Antigua and Barbuda in 2011 to that in 2012?
Provide a short and direct response. 10.91. What is the ratio of the Grants(current US$) of Botswana in 2011 to that in 2012?
Your response must be concise. 1.66. What is the ratio of the Grants(current US$) in Kenya in 2011 to that in 2012?
Offer a very short reply. 0.85. What is the ratio of the Grants(current US$) of Turkmenistan in 2011 to that in 2012?
Offer a terse response. 1.09. What is the ratio of the Grants(current US$) of Antigua and Barbuda in 2011 to that in 2013?
Your answer should be compact. 7.31. What is the ratio of the Grants(current US$) of Botswana in 2011 to that in 2013?
Offer a terse response. 1.01. What is the ratio of the Grants(current US$) in Kenya in 2011 to that in 2013?
Ensure brevity in your answer.  0.86. What is the ratio of the Grants(current US$) in Antigua and Barbuda in 2012 to that in 2013?
Offer a terse response. 0.67. What is the ratio of the Grants(current US$) in Botswana in 2012 to that in 2013?
Ensure brevity in your answer.  0.61. What is the ratio of the Grants(current US$) of Kenya in 2012 to that in 2013?
Your answer should be compact. 1.01. What is the ratio of the Grants(current US$) of Turkmenistan in 2012 to that in 2013?
Your response must be concise. 0.92. What is the difference between the highest and the second highest Grants(current US$) of Antigua and Barbuda?
Your answer should be compact. 3.77e+06. What is the difference between the highest and the second highest Grants(current US$) of Botswana?
Give a very brief answer. 4.72e+08. What is the difference between the highest and the second highest Grants(current US$) of Kenya?
Keep it short and to the point. 2.01e+07. What is the difference between the highest and the lowest Grants(current US$) of Antigua and Barbuda?
Keep it short and to the point. 1.74e+07. What is the difference between the highest and the lowest Grants(current US$) in Botswana?
Provide a short and direct response. 6.65e+08. What is the difference between the highest and the lowest Grants(current US$) of Kenya?
Offer a terse response. 7.68e+08. What is the difference between the highest and the lowest Grants(current US$) in Turkmenistan?
Your answer should be very brief. 5.20e+06. 